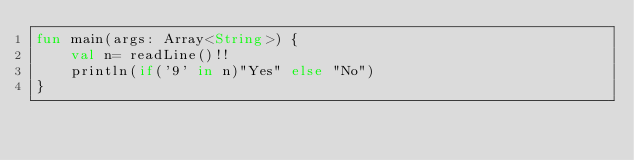Convert code to text. <code><loc_0><loc_0><loc_500><loc_500><_Kotlin_>fun main(args: Array<String>) {
    val n= readLine()!!
    println(if('9' in n)"Yes" else "No")
}</code> 